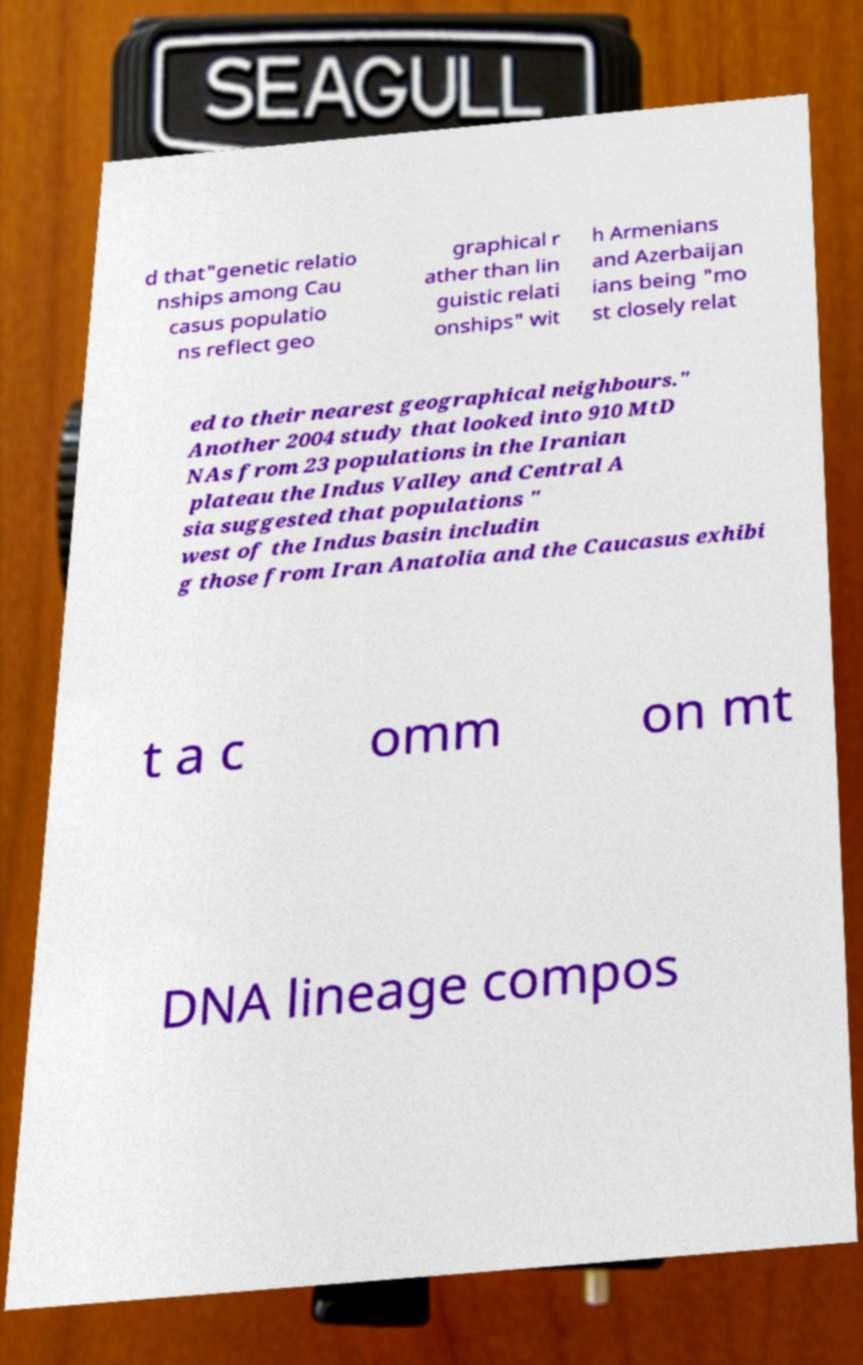Could you extract and type out the text from this image? d that"genetic relatio nships among Cau casus populatio ns reflect geo graphical r ather than lin guistic relati onships" wit h Armenians and Azerbaijan ians being "mo st closely relat ed to their nearest geographical neighbours." Another 2004 study that looked into 910 MtD NAs from 23 populations in the Iranian plateau the Indus Valley and Central A sia suggested that populations " west of the Indus basin includin g those from Iran Anatolia and the Caucasus exhibi t a c omm on mt DNA lineage compos 